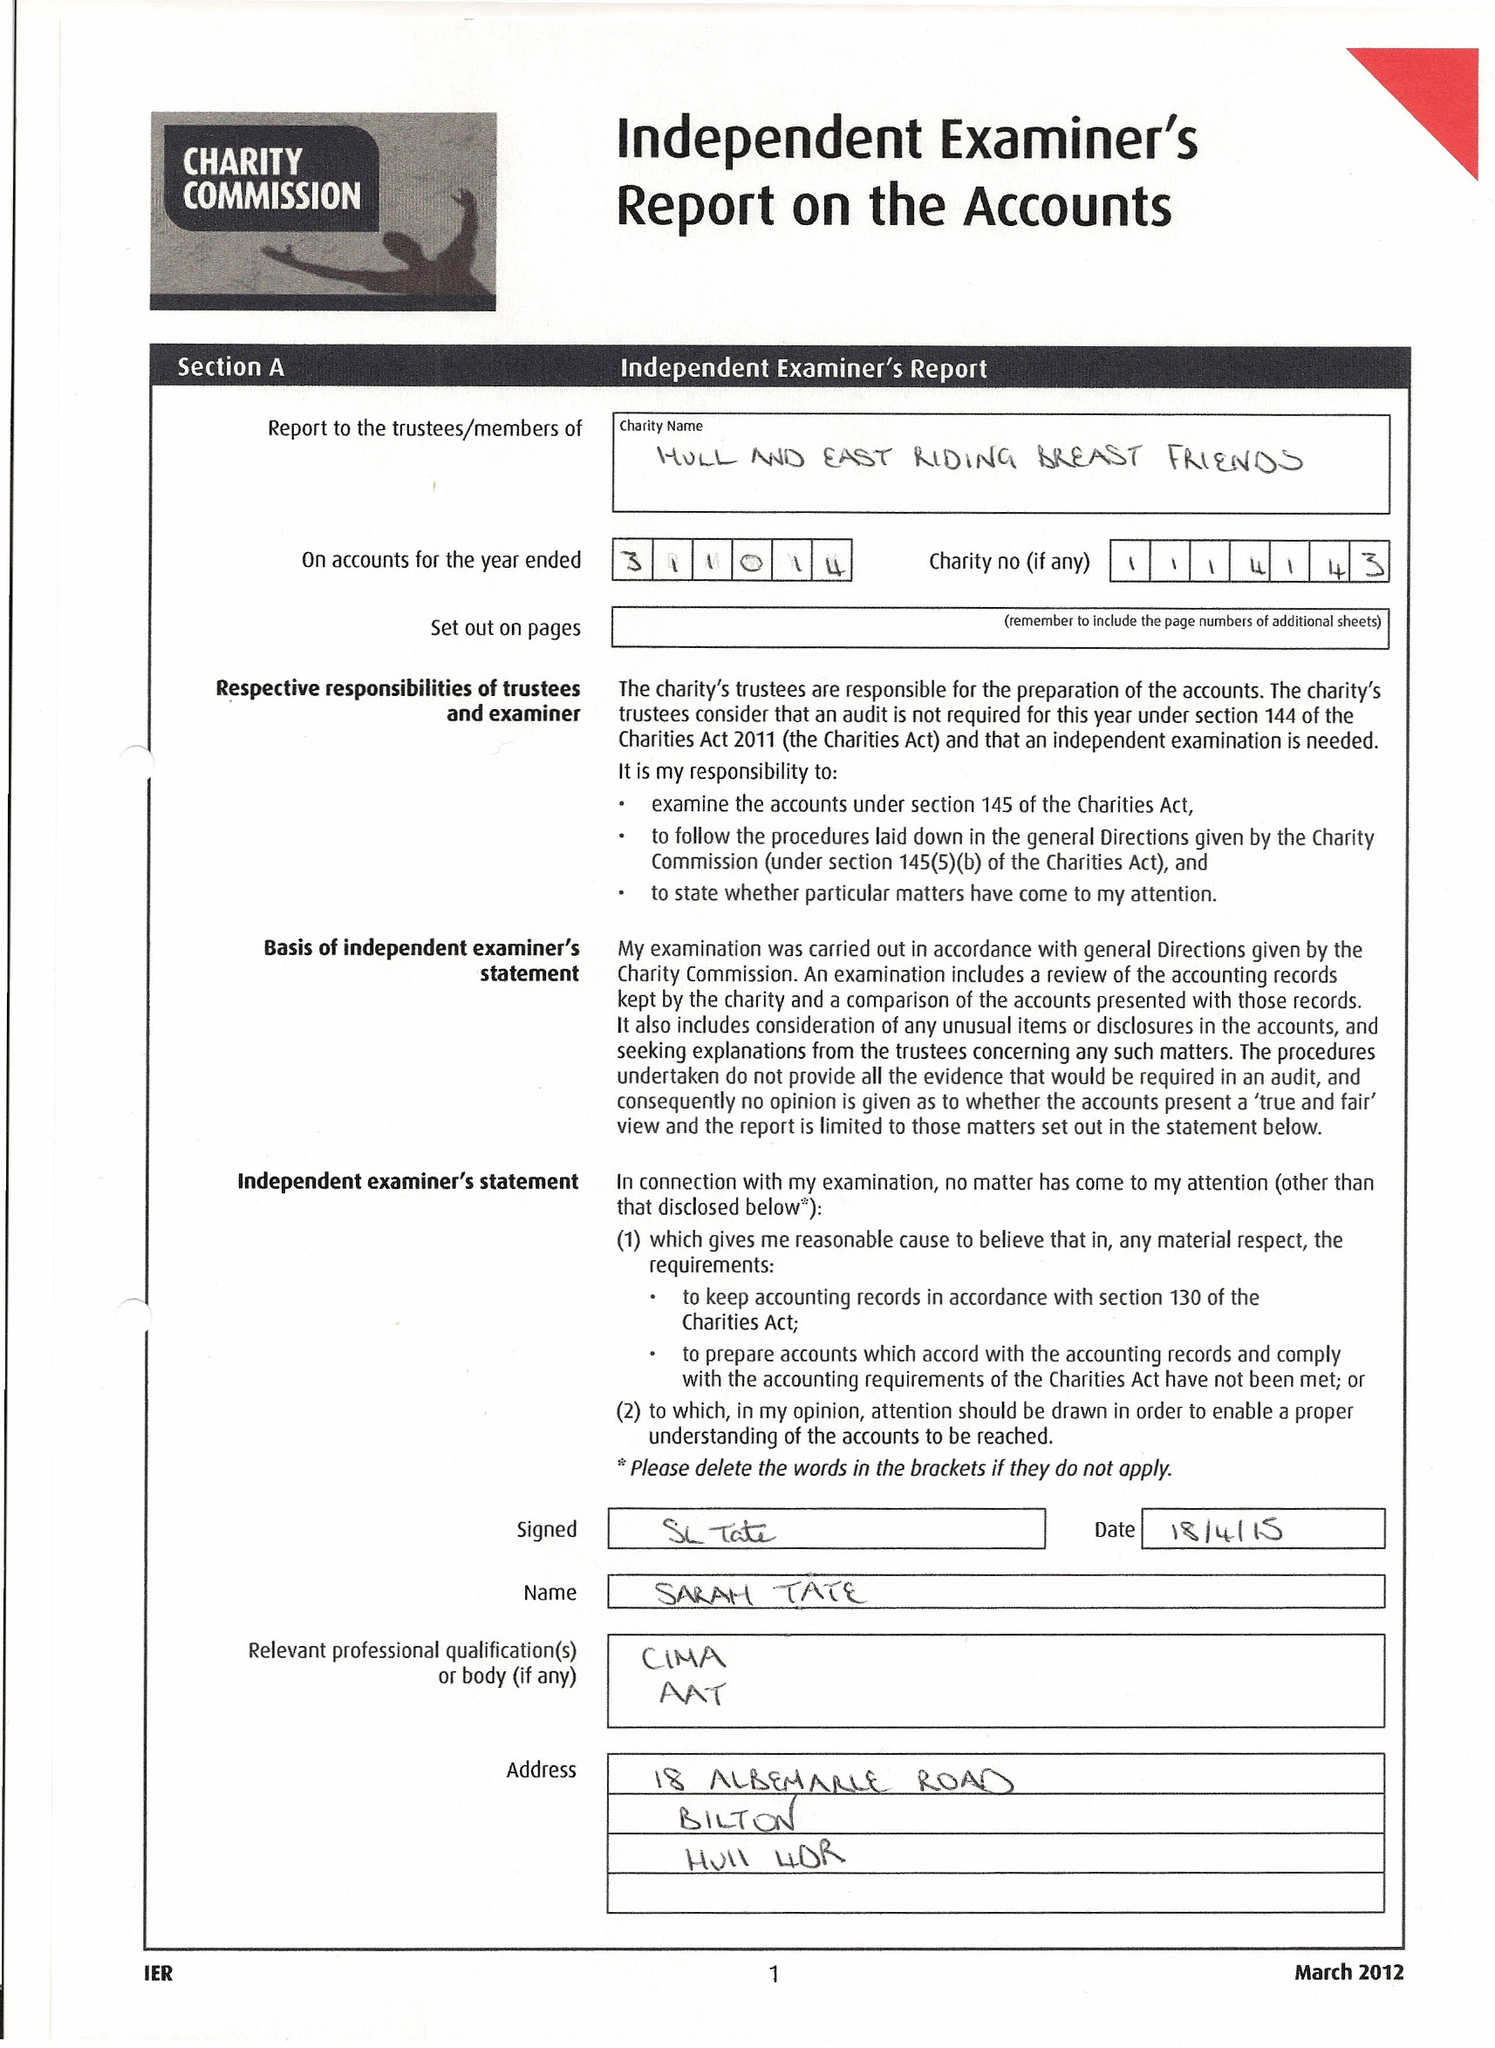What is the value for the address__postcode?
Answer the question using a single word or phrase. HU3 2RA 